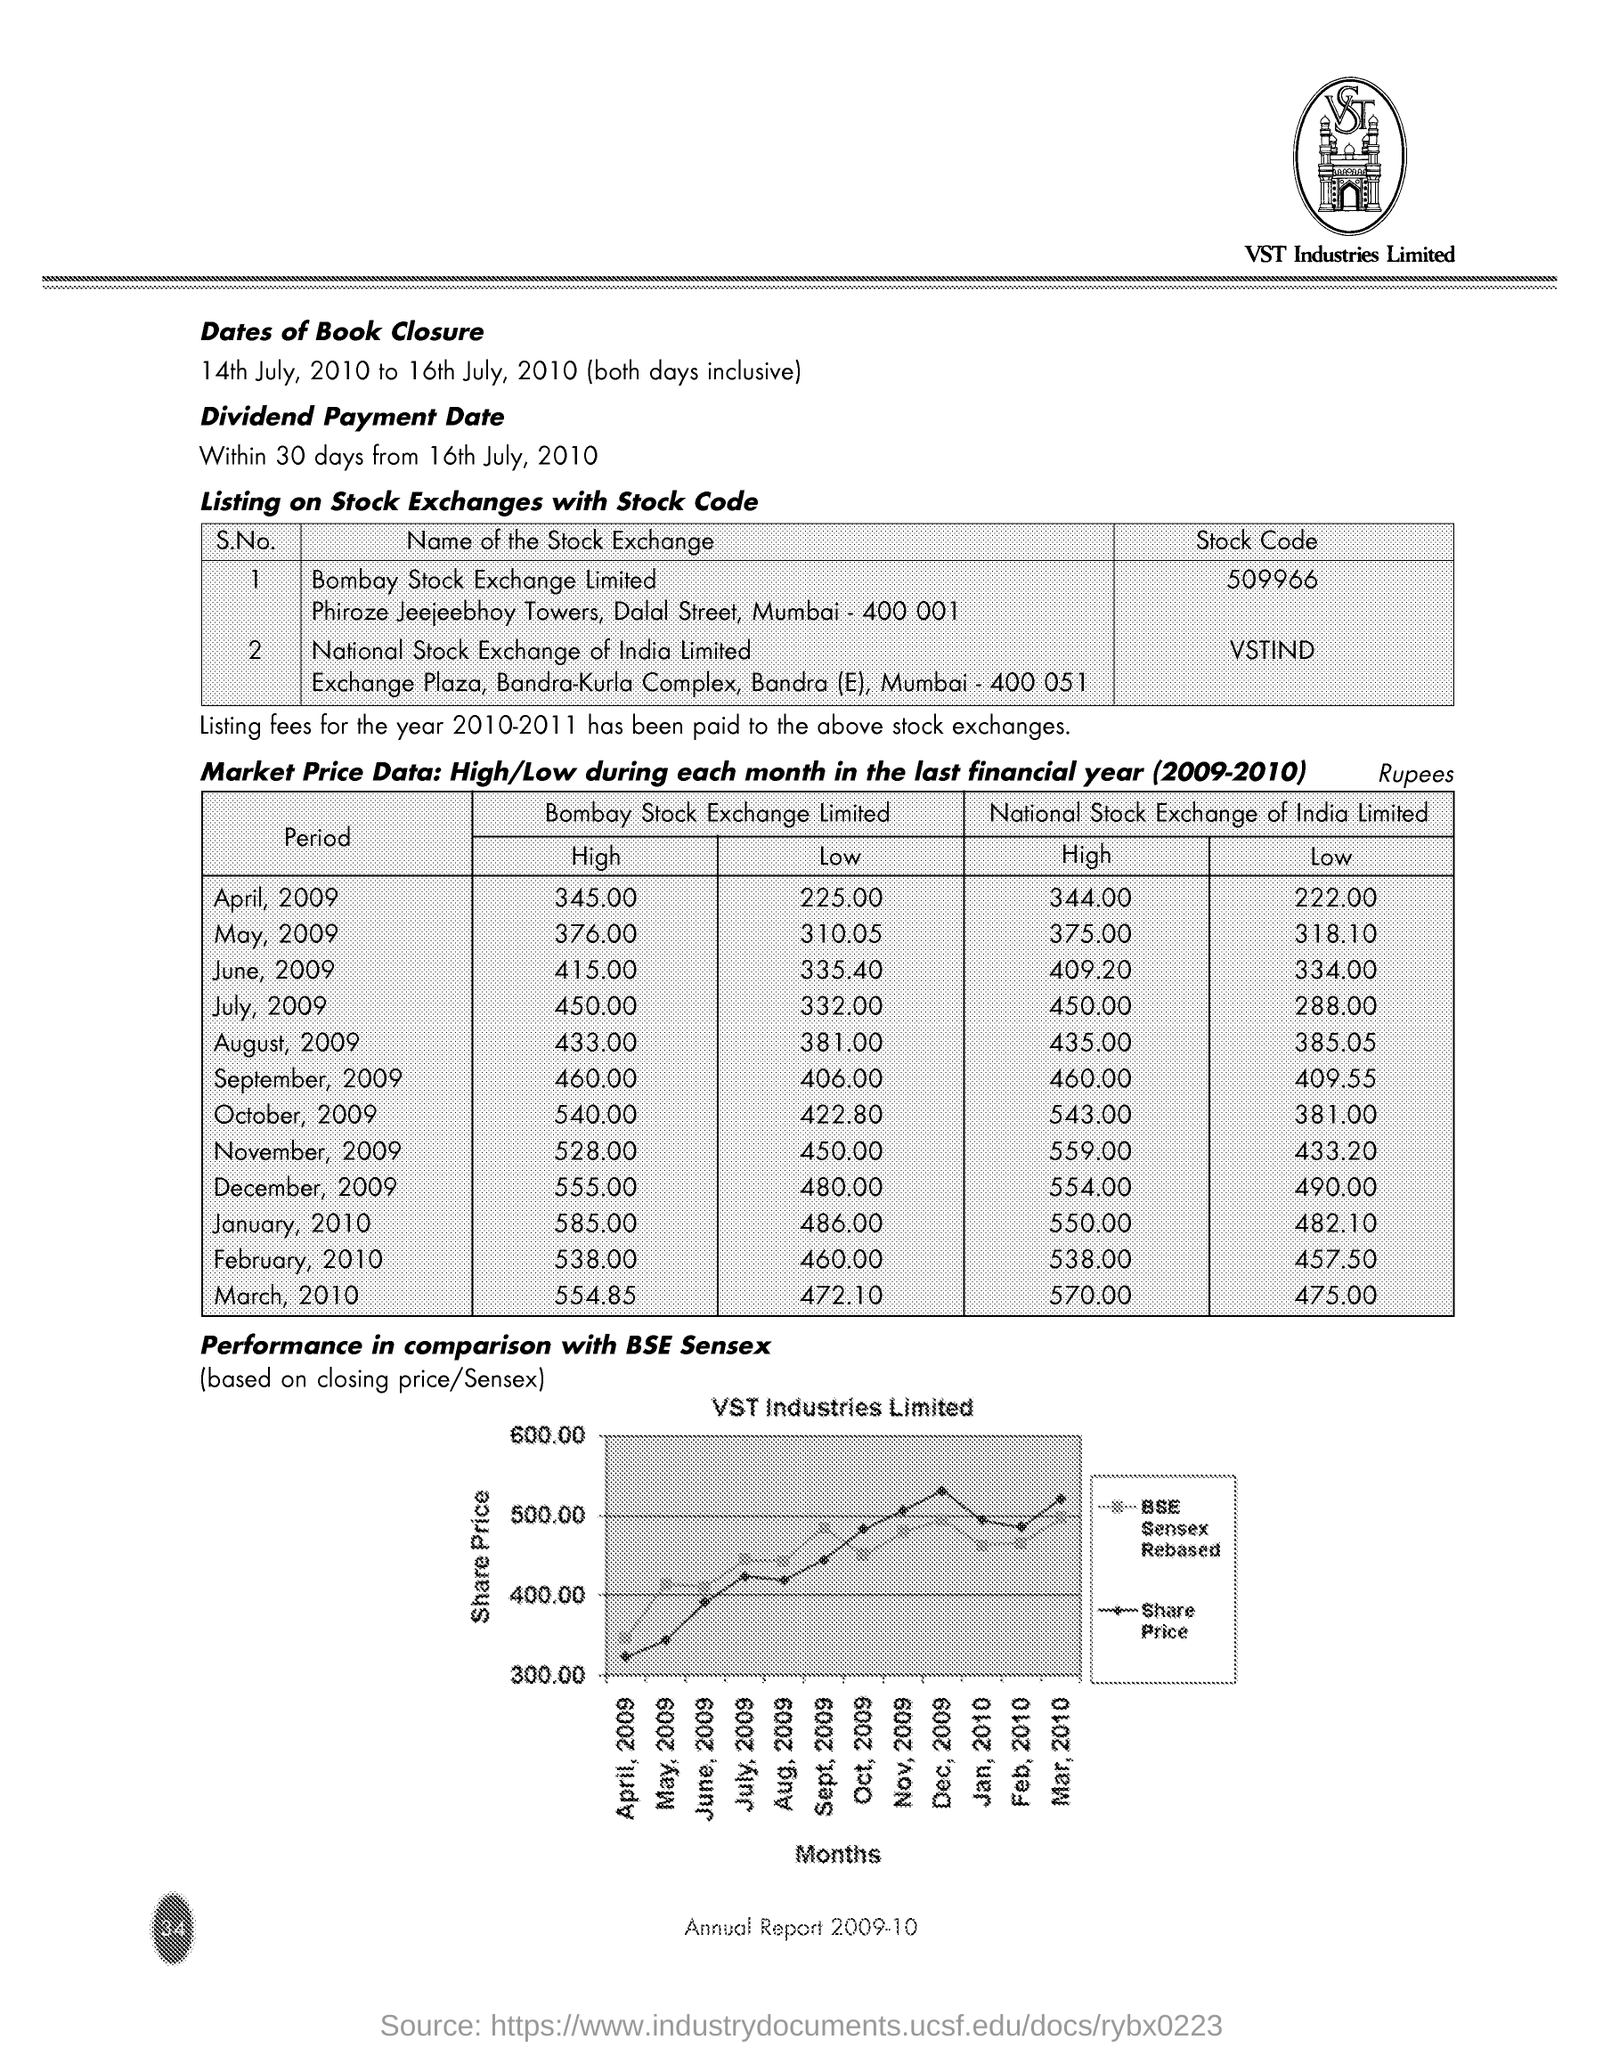Indicate a few pertinent items in this graphic. The stock code of company shares listed on the National Stock Exchange of India Limited is VSTIND. The stock code of the shares of a company listed on the Bombay Stock Exchange Limited is 509966... The document mentions VST Industries Limited in the header. The Bombay Stock Exchange recorded the lowest market share price in August 2009 at Rs. 381.00 for the financial year 2009-10. The highest market share price on Bombay Stock Exchange in April 2009 for the financial year 2009-10 was 345 rupees. 